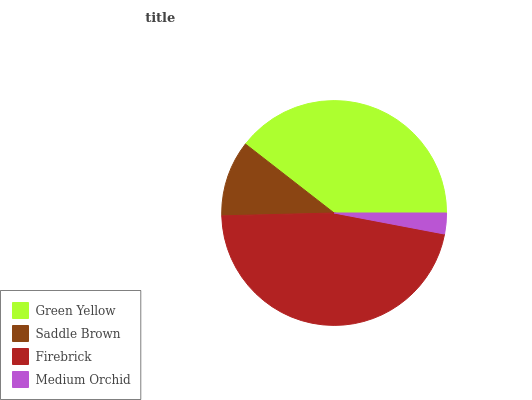Is Medium Orchid the minimum?
Answer yes or no. Yes. Is Firebrick the maximum?
Answer yes or no. Yes. Is Saddle Brown the minimum?
Answer yes or no. No. Is Saddle Brown the maximum?
Answer yes or no. No. Is Green Yellow greater than Saddle Brown?
Answer yes or no. Yes. Is Saddle Brown less than Green Yellow?
Answer yes or no. Yes. Is Saddle Brown greater than Green Yellow?
Answer yes or no. No. Is Green Yellow less than Saddle Brown?
Answer yes or no. No. Is Green Yellow the high median?
Answer yes or no. Yes. Is Saddle Brown the low median?
Answer yes or no. Yes. Is Medium Orchid the high median?
Answer yes or no. No. Is Medium Orchid the low median?
Answer yes or no. No. 